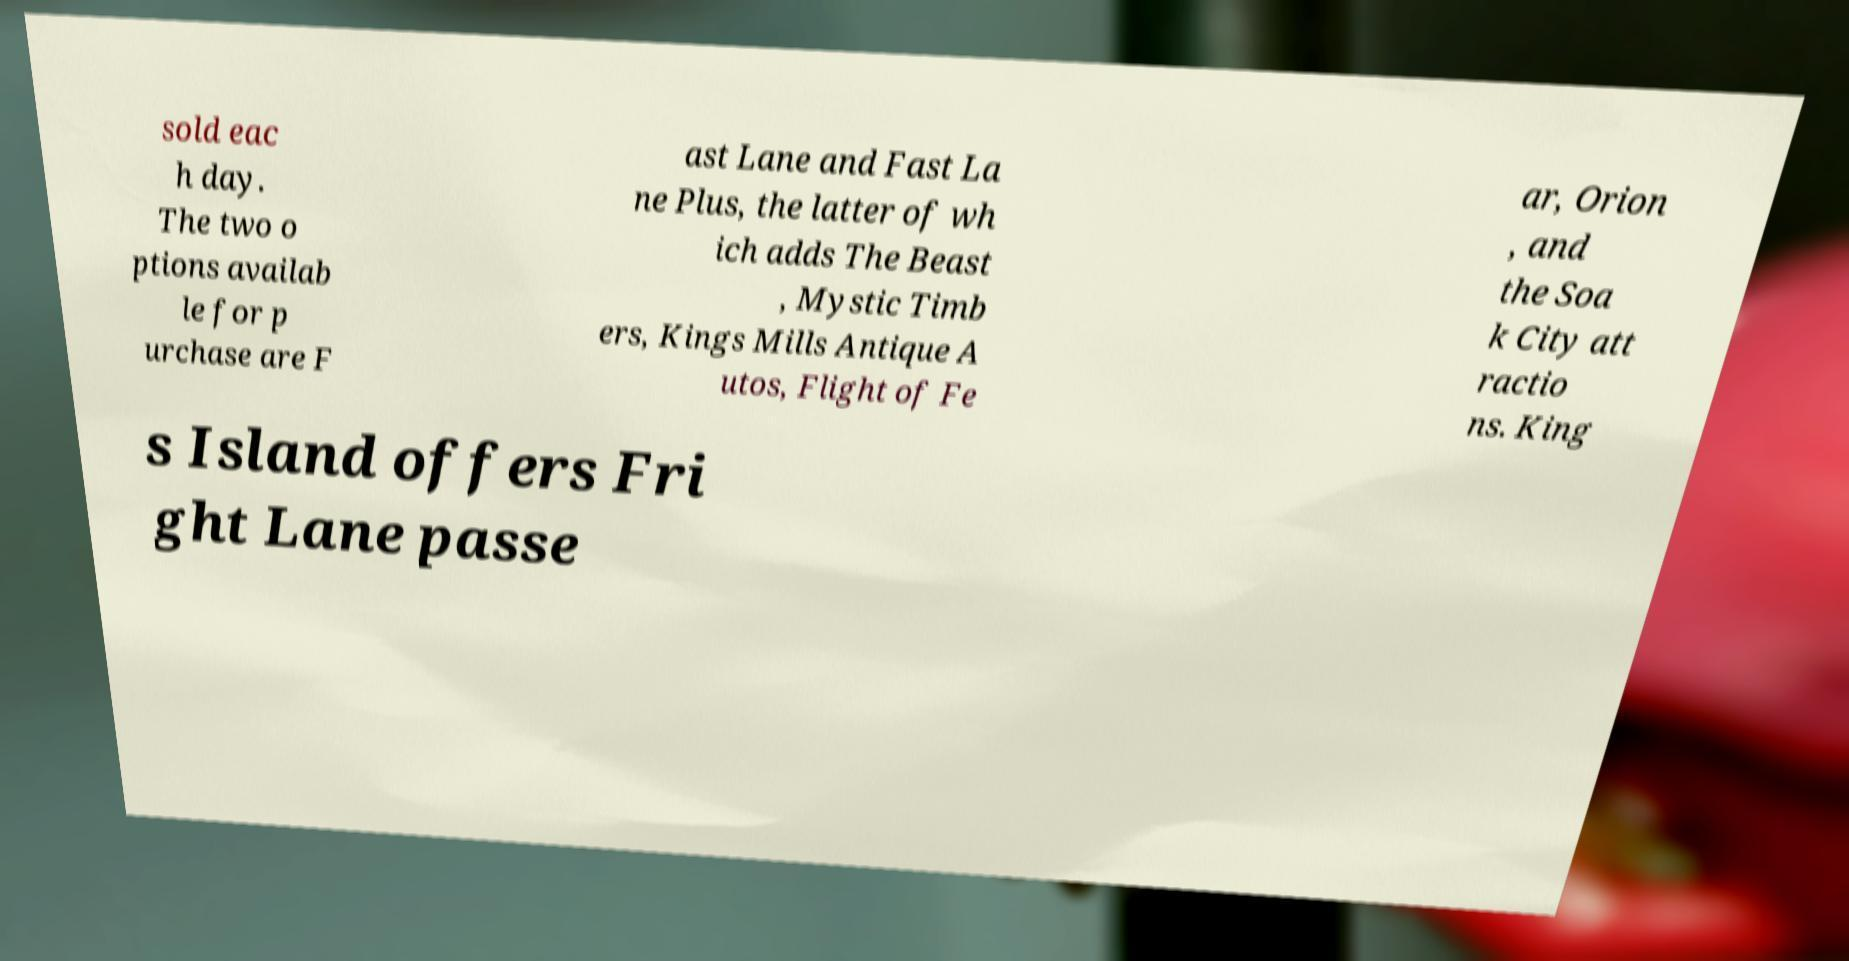For documentation purposes, I need the text within this image transcribed. Could you provide that? sold eac h day. The two o ptions availab le for p urchase are F ast Lane and Fast La ne Plus, the latter of wh ich adds The Beast , Mystic Timb ers, Kings Mills Antique A utos, Flight of Fe ar, Orion , and the Soa k City att ractio ns. King s Island offers Fri ght Lane passe 